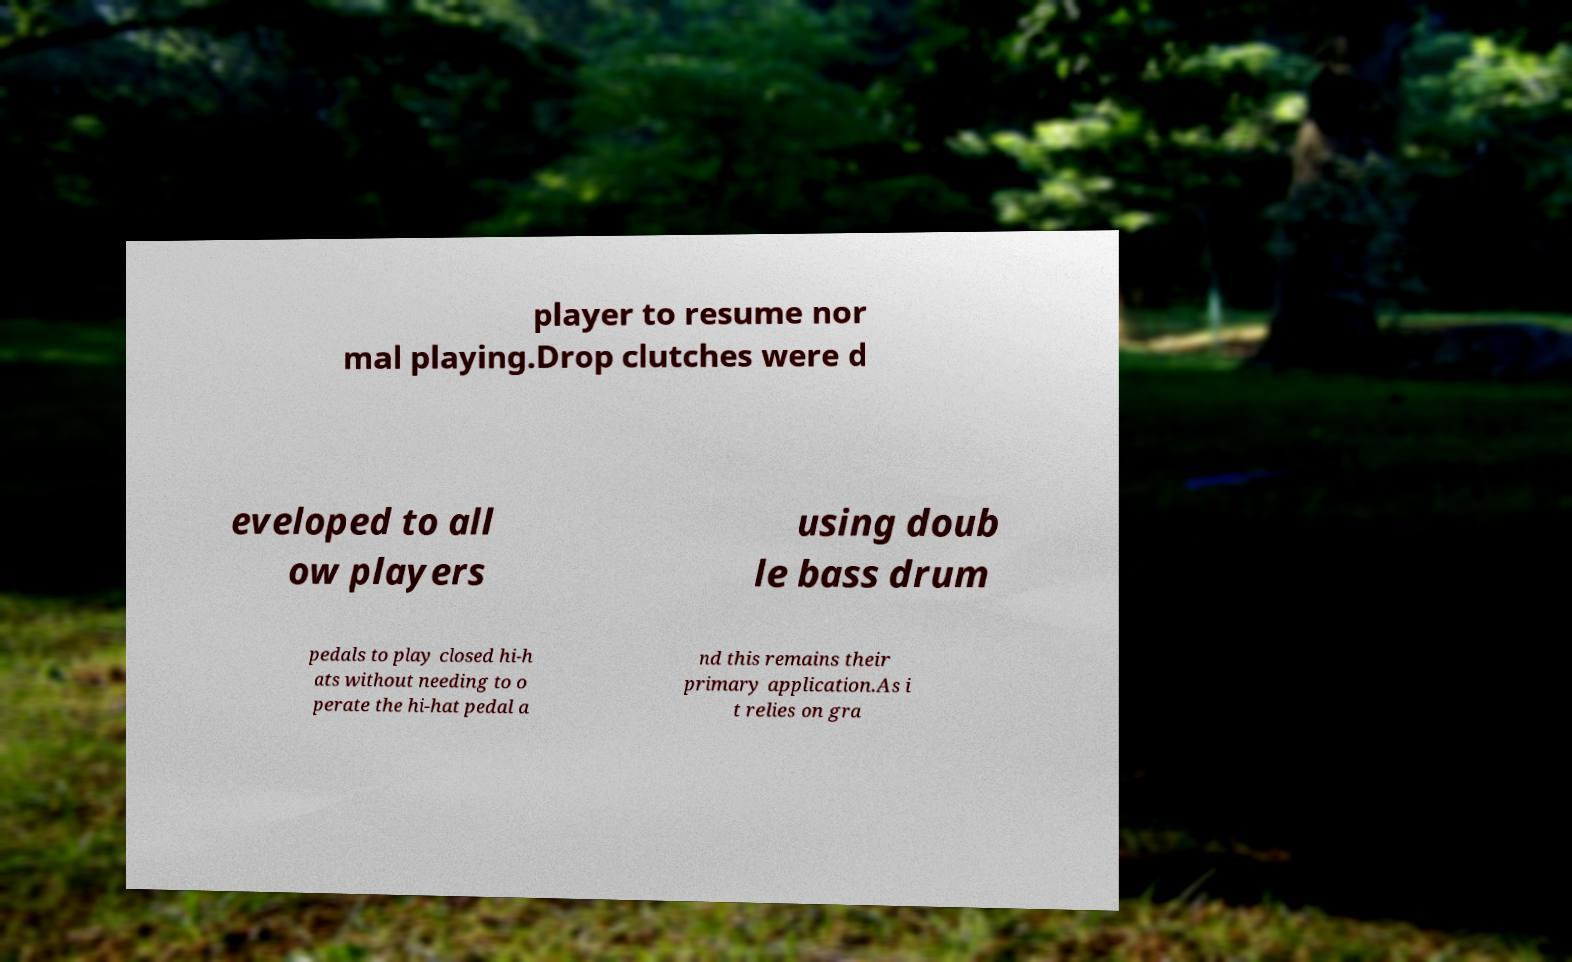Could you extract and type out the text from this image? player to resume nor mal playing.Drop clutches were d eveloped to all ow players using doub le bass drum pedals to play closed hi-h ats without needing to o perate the hi-hat pedal a nd this remains their primary application.As i t relies on gra 